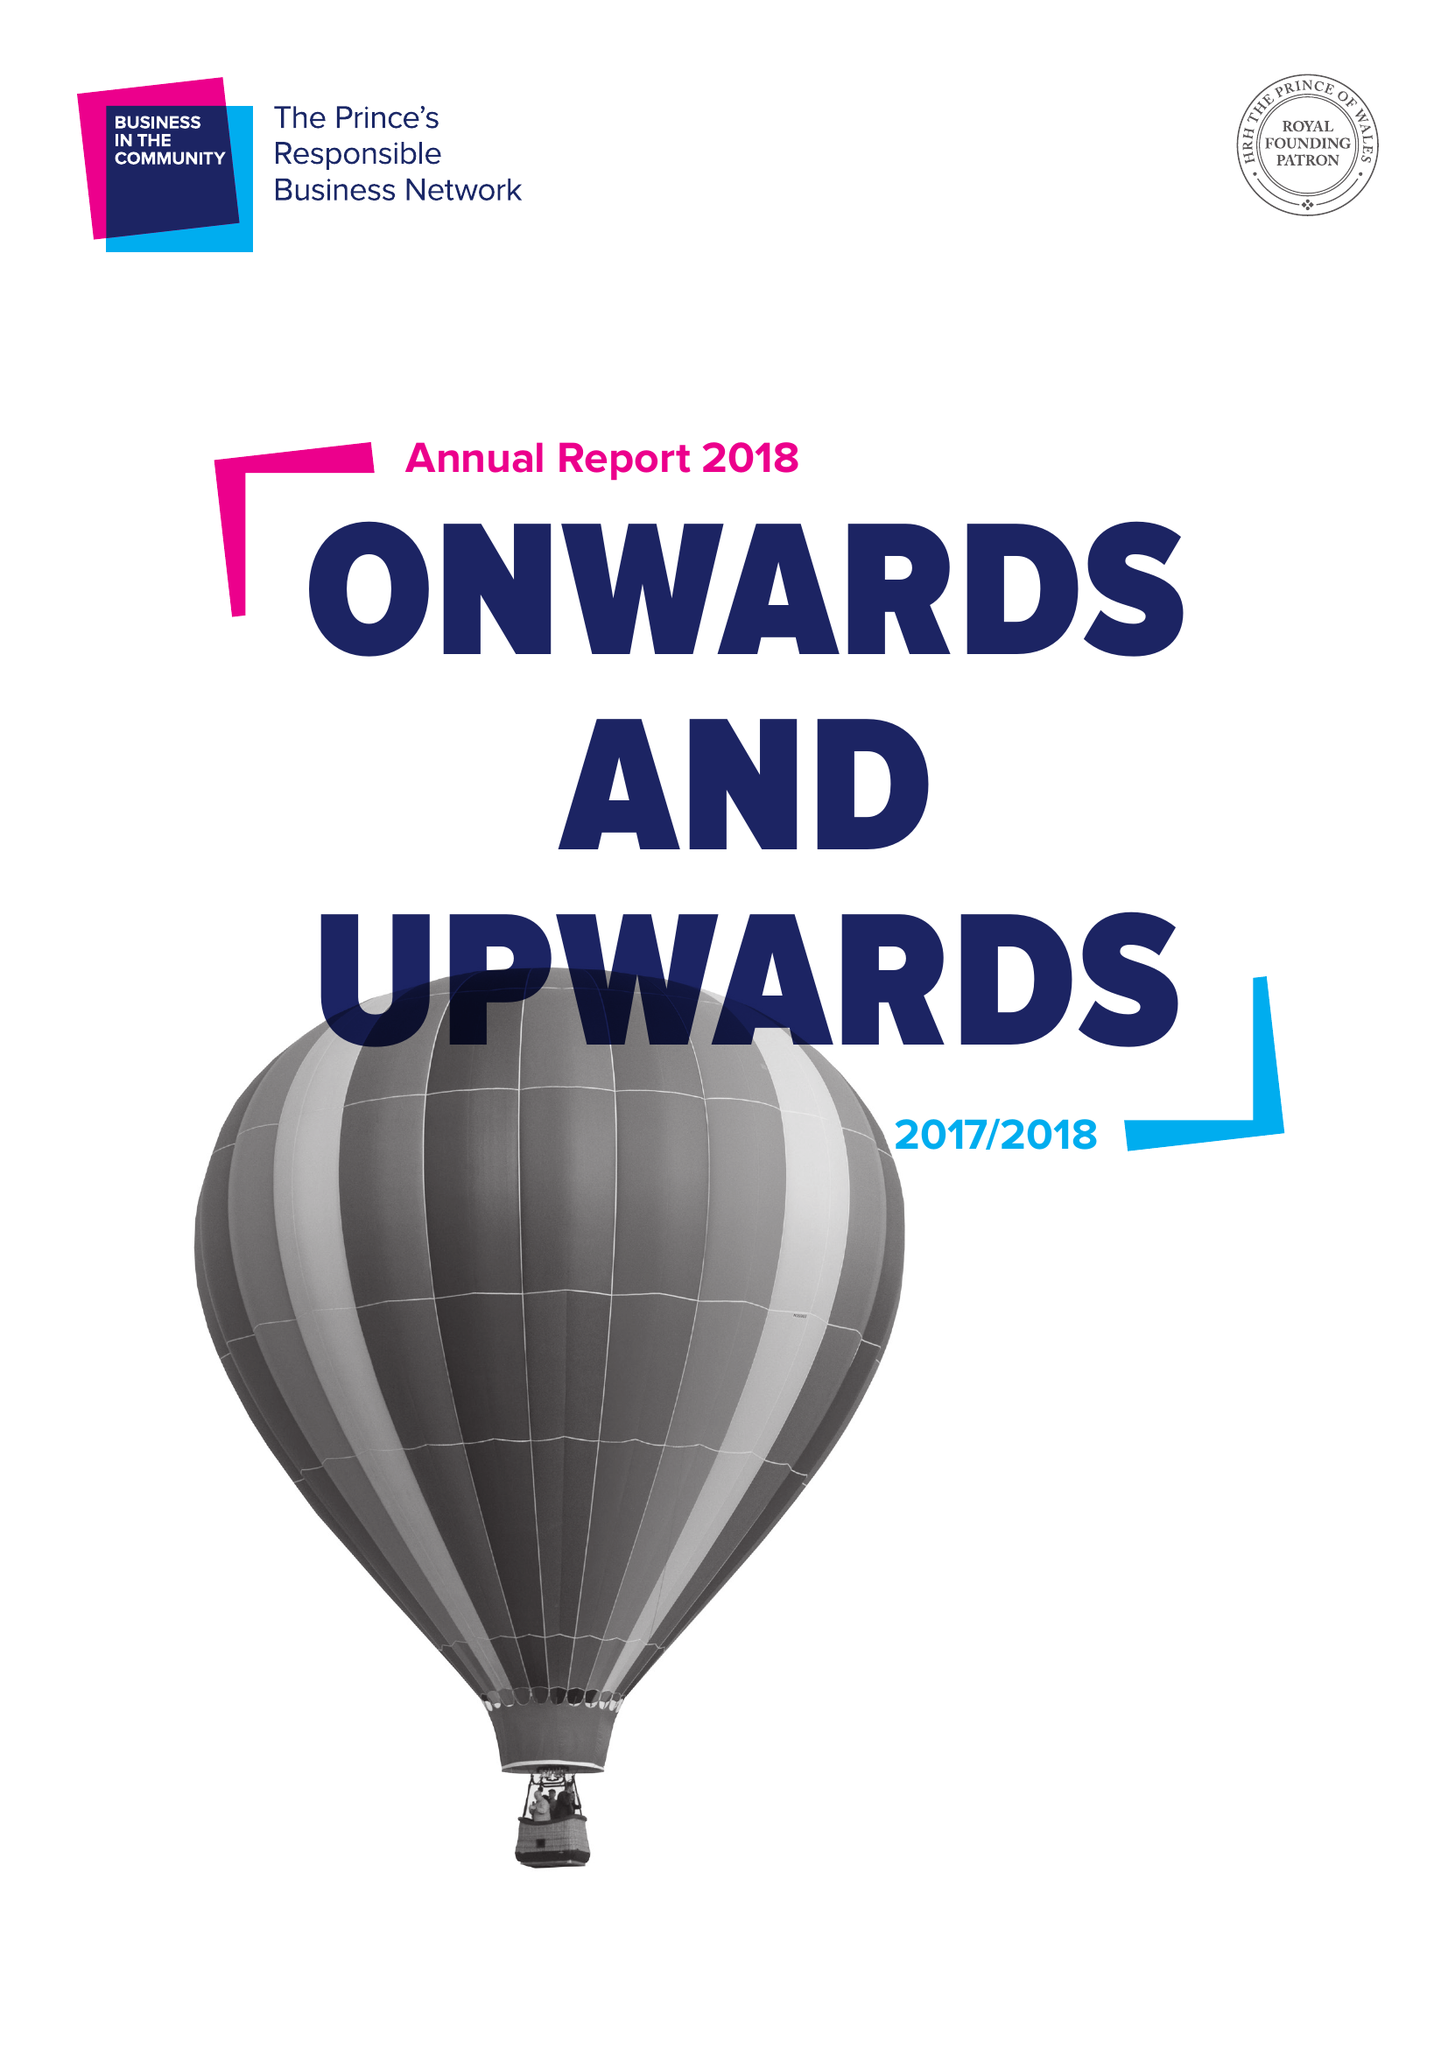What is the value for the address__postcode?
Answer the question using a single word or phrase. N1 7RQ 